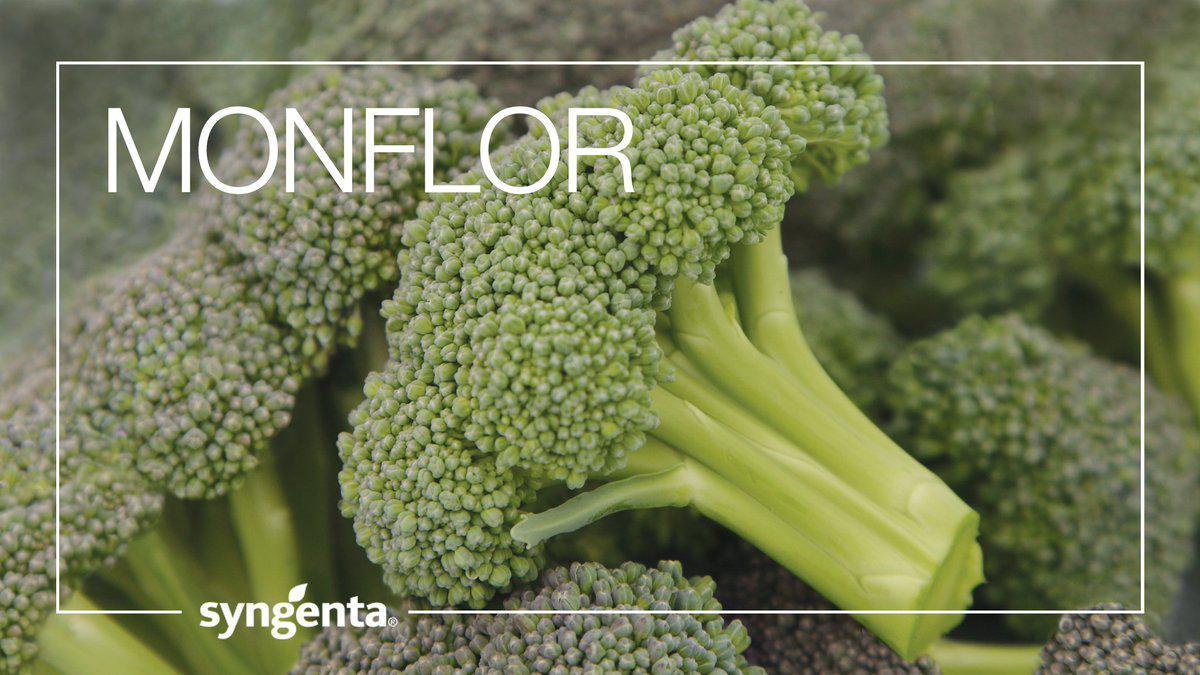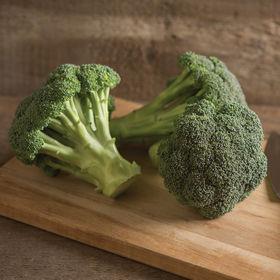The first image is the image on the left, the second image is the image on the right. Assess this claim about the two images: "In the image to the left, you're able to see some of the broad leaves of the broccoli plant.". Correct or not? Answer yes or no. No. 